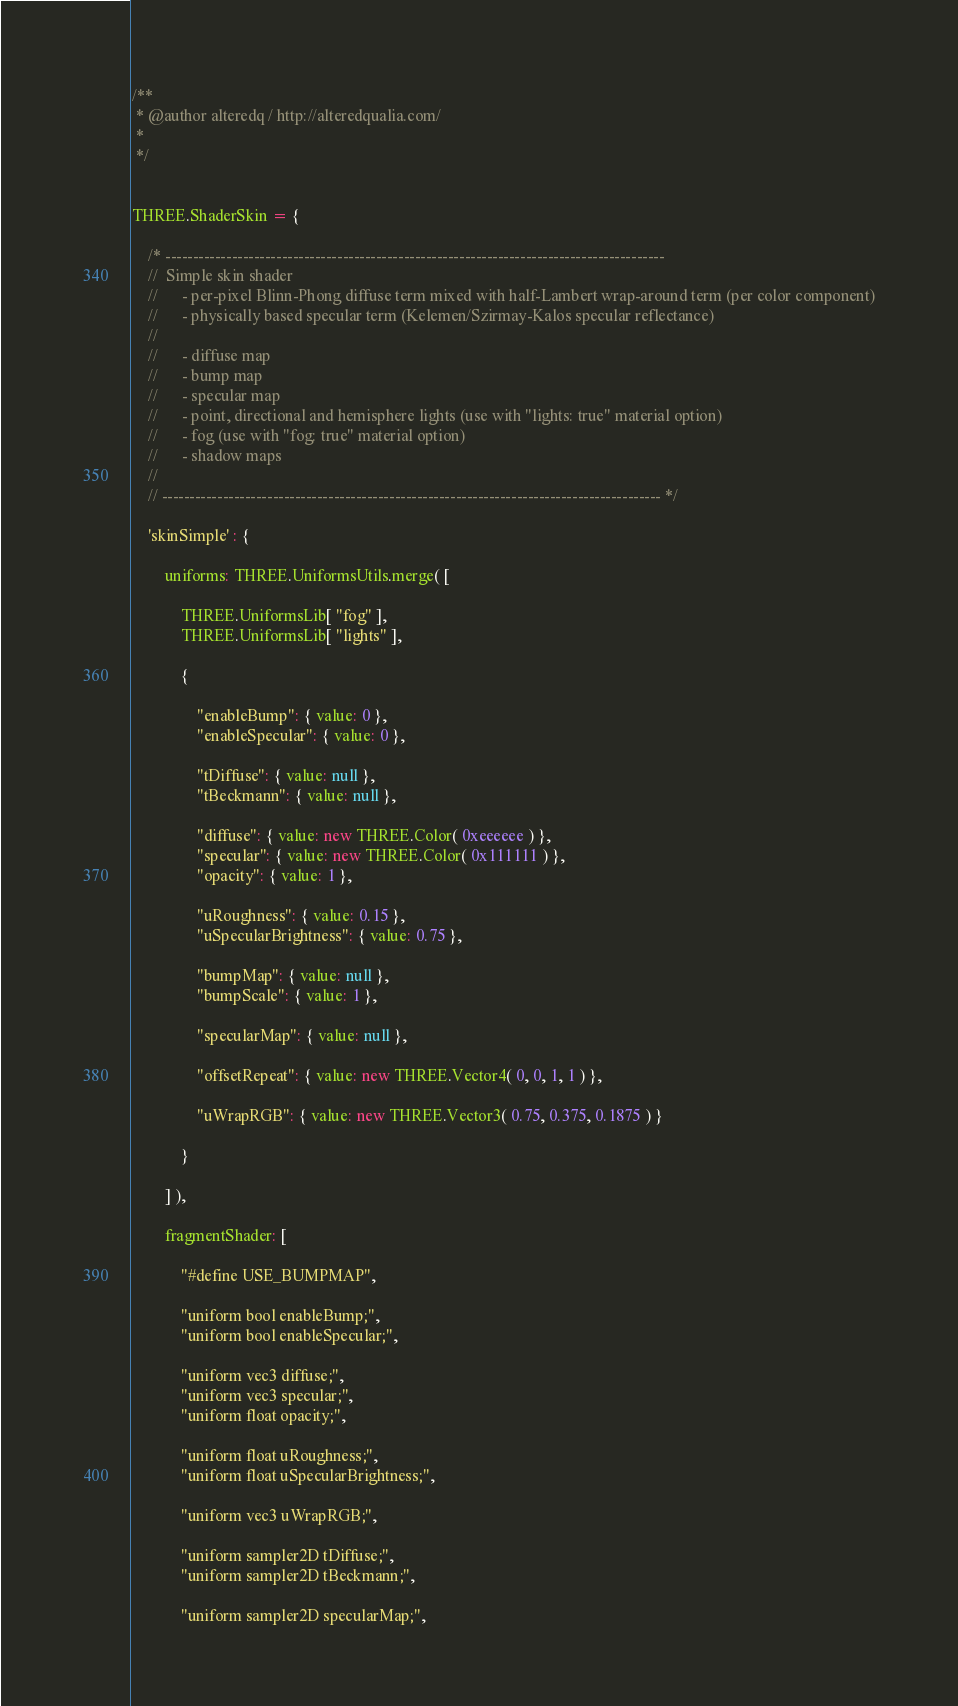Convert code to text. <code><loc_0><loc_0><loc_500><loc_500><_JavaScript_>/**
 * @author alteredq / http://alteredqualia.com/
 *
 */


THREE.ShaderSkin = {

	/* ------------------------------------------------------------------------------------------
	//	Simple skin shader
	//		- per-pixel Blinn-Phong diffuse term mixed with half-Lambert wrap-around term (per color component)
	//		- physically based specular term (Kelemen/Szirmay-Kalos specular reflectance)
	//
	//		- diffuse map
	//		- bump map
	//		- specular map
	//		- point, directional and hemisphere lights (use with "lights: true" material option)
	//		- fog (use with "fog: true" material option)
	//		- shadow maps
	//
	// ------------------------------------------------------------------------------------------ */

	'skinSimple' : {

		uniforms: THREE.UniformsUtils.merge( [

			THREE.UniformsLib[ "fog" ],
			THREE.UniformsLib[ "lights" ],

			{

				"enableBump": { value: 0 },
				"enableSpecular": { value: 0 },

				"tDiffuse": { value: null },
				"tBeckmann": { value: null },

				"diffuse": { value: new THREE.Color( 0xeeeeee ) },
				"specular": { value: new THREE.Color( 0x111111 ) },
				"opacity": { value: 1 },

				"uRoughness": { value: 0.15 },
				"uSpecularBrightness": { value: 0.75 },

				"bumpMap": { value: null },
				"bumpScale": { value: 1 },

				"specularMap": { value: null },

				"offsetRepeat": { value: new THREE.Vector4( 0, 0, 1, 1 ) },

				"uWrapRGB": { value: new THREE.Vector3( 0.75, 0.375, 0.1875 ) }

			}

		] ),

		fragmentShader: [

			"#define USE_BUMPMAP",

			"uniform bool enableBump;",
			"uniform bool enableSpecular;",

			"uniform vec3 diffuse;",
			"uniform vec3 specular;",
			"uniform float opacity;",

			"uniform float uRoughness;",
			"uniform float uSpecularBrightness;",

			"uniform vec3 uWrapRGB;",

			"uniform sampler2D tDiffuse;",
			"uniform sampler2D tBeckmann;",

			"uniform sampler2D specularMap;",
</code> 